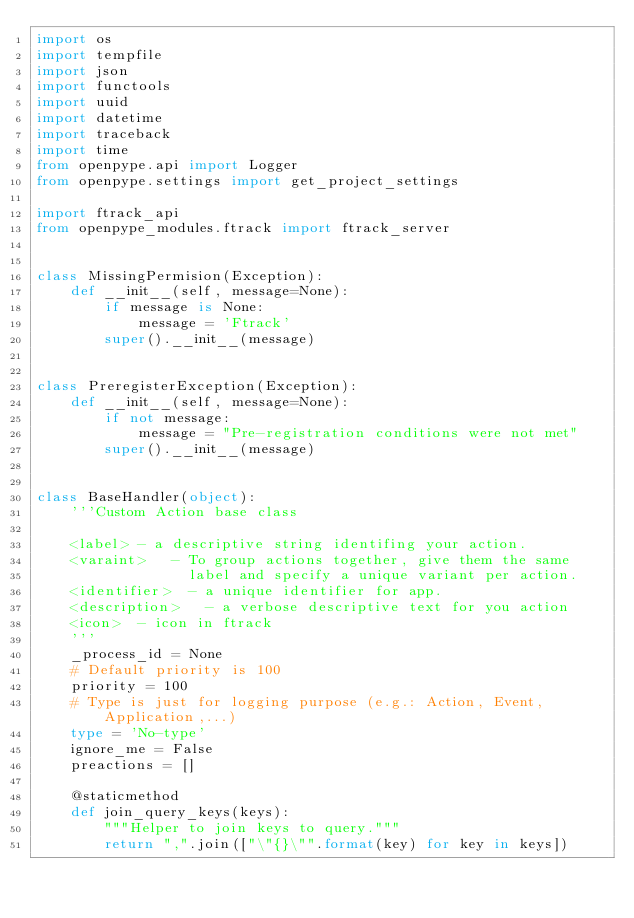Convert code to text. <code><loc_0><loc_0><loc_500><loc_500><_Python_>import os
import tempfile
import json
import functools
import uuid
import datetime
import traceback
import time
from openpype.api import Logger
from openpype.settings import get_project_settings

import ftrack_api
from openpype_modules.ftrack import ftrack_server


class MissingPermision(Exception):
    def __init__(self, message=None):
        if message is None:
            message = 'Ftrack'
        super().__init__(message)


class PreregisterException(Exception):
    def __init__(self, message=None):
        if not message:
            message = "Pre-registration conditions were not met"
        super().__init__(message)


class BaseHandler(object):
    '''Custom Action base class

    <label> - a descriptive string identifing your action.
    <varaint>   - To group actions together, give them the same
                  label and specify a unique variant per action.
    <identifier>  - a unique identifier for app.
    <description>   - a verbose descriptive text for you action
    <icon>  - icon in ftrack
    '''
    _process_id = None
    # Default priority is 100
    priority = 100
    # Type is just for logging purpose (e.g.: Action, Event, Application,...)
    type = 'No-type'
    ignore_me = False
    preactions = []

    @staticmethod
    def join_query_keys(keys):
        """Helper to join keys to query."""
        return ",".join(["\"{}\"".format(key) for key in keys])
</code> 